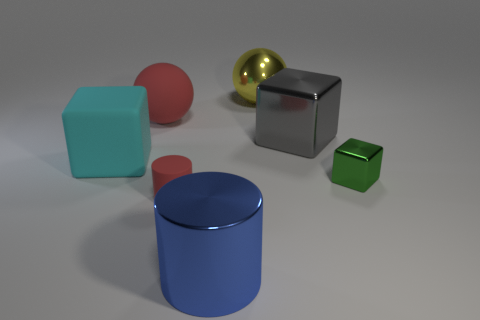There is a sphere that is in front of the yellow sphere; is its size the same as the thing that is in front of the matte cylinder?
Your response must be concise. Yes. There is a ball right of the large ball that is to the left of the yellow object; what is its material?
Make the answer very short. Metal. Is the number of small green metal objects that are left of the large yellow ball less than the number of gray shiny blocks?
Ensure brevity in your answer.  Yes. There is a large blue object that is made of the same material as the small green cube; what is its shape?
Make the answer very short. Cylinder. How many other things are there of the same shape as the small metallic thing?
Your answer should be compact. 2. What number of purple objects are big cubes or big rubber objects?
Your response must be concise. 0. Does the small red rubber object have the same shape as the green object?
Your answer should be very brief. No. There is a red matte thing that is behind the green metal thing; is there a shiny cylinder that is in front of it?
Give a very brief answer. Yes. Is the number of tiny cylinders on the right side of the large gray cube the same as the number of blue metallic cylinders?
Provide a short and direct response. No. What number of other things are the same size as the blue cylinder?
Make the answer very short. 4. 